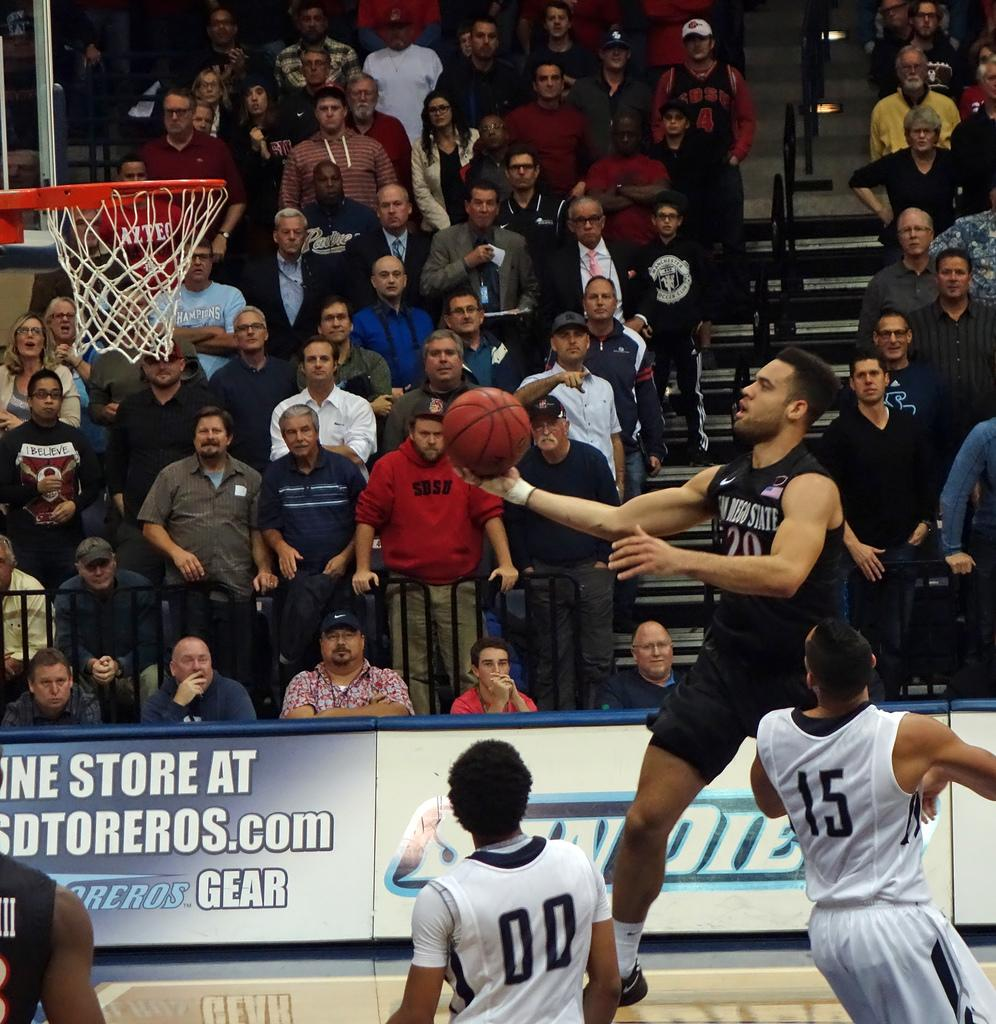<image>
Write a terse but informative summary of the picture. A basketball player with a black uniform is jumping toward the hoop with another player having the number 15 on his back. 